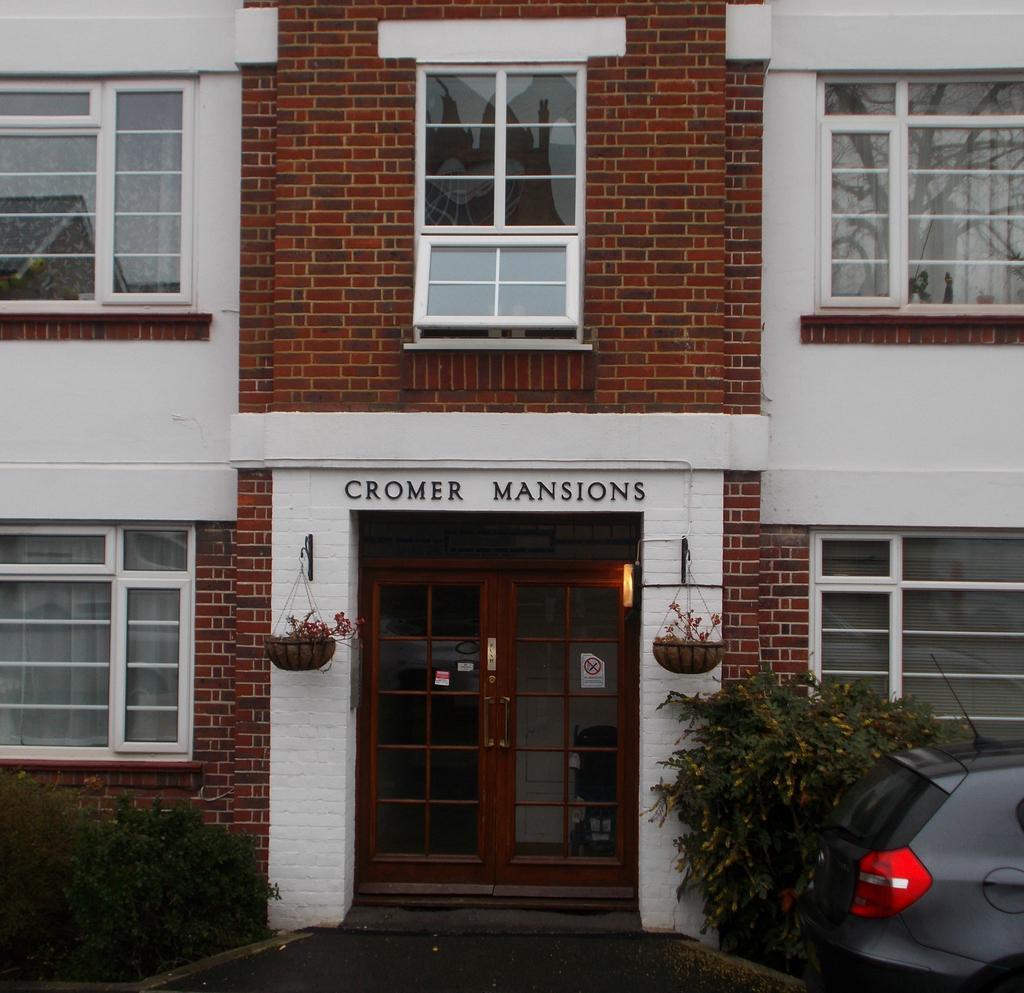Describe this image in one or two sentences. In the picture I can see a building which has doors, windows and flower pots attached to the wall. I can also see vehicle, plants and something written on the building. 